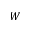Convert formula to latex. <formula><loc_0><loc_0><loc_500><loc_500>W</formula> 